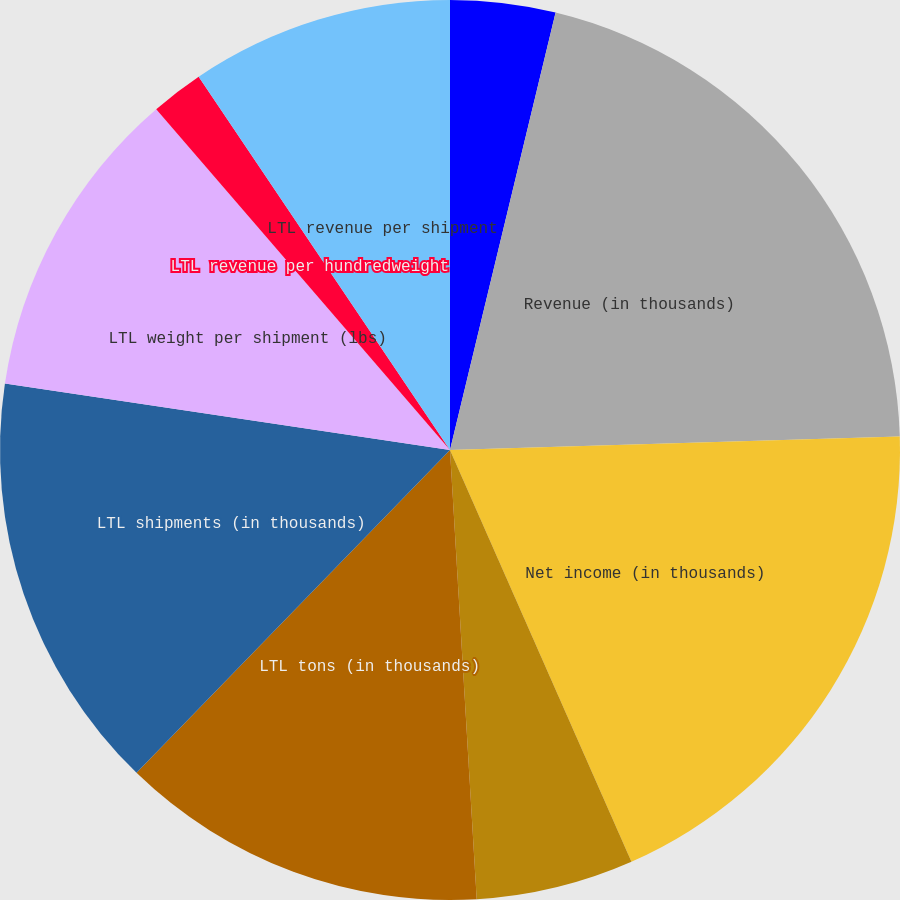Convert chart. <chart><loc_0><loc_0><loc_500><loc_500><pie_chart><fcel>Work days<fcel>Revenue (in thousands)<fcel>Net income (in thousands)<fcel>Diluted earnings per share<fcel>LTL tons (in thousands)<fcel>LTL shipments (in thousands)<fcel>LTL weight per shipment (lbs)<fcel>LTL revenue per hundredweight<fcel>LTL revenue per shipment<fcel>LTL revenue per intercity mile<nl><fcel>3.77%<fcel>20.75%<fcel>18.87%<fcel>5.66%<fcel>13.21%<fcel>15.09%<fcel>11.32%<fcel>1.89%<fcel>9.43%<fcel>0.0%<nl></chart> 